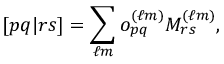<formula> <loc_0><loc_0><loc_500><loc_500>[ p q | r s ] = \sum _ { \ell m } o _ { p q } ^ { ( \ell m ) } M _ { r s } ^ { ( \ell m ) } ,</formula> 